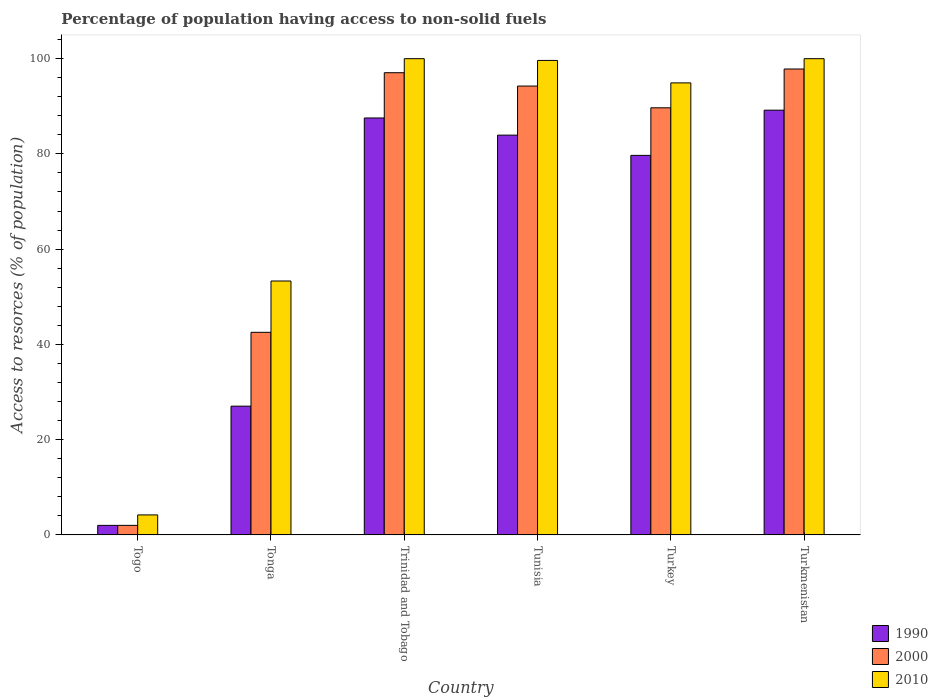How many groups of bars are there?
Offer a very short reply. 6. Are the number of bars on each tick of the X-axis equal?
Give a very brief answer. Yes. How many bars are there on the 1st tick from the left?
Provide a succinct answer. 3. How many bars are there on the 5th tick from the right?
Ensure brevity in your answer.  3. What is the label of the 2nd group of bars from the left?
Offer a terse response. Tonga. What is the percentage of population having access to non-solid fuels in 1990 in Tonga?
Give a very brief answer. 27.03. Across all countries, what is the maximum percentage of population having access to non-solid fuels in 2000?
Provide a short and direct response. 97.82. Across all countries, what is the minimum percentage of population having access to non-solid fuels in 2010?
Your answer should be compact. 4.19. In which country was the percentage of population having access to non-solid fuels in 2000 maximum?
Ensure brevity in your answer.  Turkmenistan. In which country was the percentage of population having access to non-solid fuels in 2000 minimum?
Provide a short and direct response. Togo. What is the total percentage of population having access to non-solid fuels in 2000 in the graph?
Provide a succinct answer. 423.32. What is the difference between the percentage of population having access to non-solid fuels in 1990 in Tonga and that in Trinidad and Tobago?
Ensure brevity in your answer.  -60.51. What is the difference between the percentage of population having access to non-solid fuels in 2010 in Tunisia and the percentage of population having access to non-solid fuels in 1990 in Turkey?
Your response must be concise. 19.94. What is the average percentage of population having access to non-solid fuels in 2010 per country?
Your answer should be very brief. 75.34. What is the difference between the percentage of population having access to non-solid fuels of/in 2000 and percentage of population having access to non-solid fuels of/in 1990 in Tonga?
Your answer should be compact. 15.51. What is the ratio of the percentage of population having access to non-solid fuels in 2010 in Tonga to that in Turkey?
Your answer should be compact. 0.56. Is the difference between the percentage of population having access to non-solid fuels in 2000 in Trinidad and Tobago and Turkey greater than the difference between the percentage of population having access to non-solid fuels in 1990 in Trinidad and Tobago and Turkey?
Offer a very short reply. No. What is the difference between the highest and the second highest percentage of population having access to non-solid fuels in 2000?
Provide a short and direct response. -3.58. What is the difference between the highest and the lowest percentage of population having access to non-solid fuels in 2010?
Your response must be concise. 95.8. Is the sum of the percentage of population having access to non-solid fuels in 1990 in Trinidad and Tobago and Turkey greater than the maximum percentage of population having access to non-solid fuels in 2010 across all countries?
Your answer should be compact. Yes. What does the 2nd bar from the left in Togo represents?
Your response must be concise. 2000. Is it the case that in every country, the sum of the percentage of population having access to non-solid fuels in 2000 and percentage of population having access to non-solid fuels in 1990 is greater than the percentage of population having access to non-solid fuels in 2010?
Your answer should be compact. No. How many bars are there?
Offer a terse response. 18. Are all the bars in the graph horizontal?
Your response must be concise. No. What is the difference between two consecutive major ticks on the Y-axis?
Your answer should be compact. 20. Does the graph contain any zero values?
Offer a terse response. No. Does the graph contain grids?
Provide a succinct answer. No. Where does the legend appear in the graph?
Offer a very short reply. Bottom right. How many legend labels are there?
Ensure brevity in your answer.  3. What is the title of the graph?
Ensure brevity in your answer.  Percentage of population having access to non-solid fuels. What is the label or title of the Y-axis?
Keep it short and to the point. Access to resorces (% of population). What is the Access to resorces (% of population) in 1990 in Togo?
Keep it short and to the point. 2. What is the Access to resorces (% of population) of 2000 in Togo?
Make the answer very short. 2. What is the Access to resorces (% of population) of 2010 in Togo?
Your answer should be compact. 4.19. What is the Access to resorces (% of population) of 1990 in Tonga?
Offer a terse response. 27.03. What is the Access to resorces (% of population) in 2000 in Tonga?
Give a very brief answer. 42.54. What is the Access to resorces (% of population) in 2010 in Tonga?
Your response must be concise. 53.31. What is the Access to resorces (% of population) in 1990 in Trinidad and Tobago?
Give a very brief answer. 87.54. What is the Access to resorces (% of population) of 2000 in Trinidad and Tobago?
Your answer should be very brief. 97.04. What is the Access to resorces (% of population) of 2010 in Trinidad and Tobago?
Your answer should be compact. 99.99. What is the Access to resorces (% of population) in 1990 in Tunisia?
Offer a very short reply. 83.94. What is the Access to resorces (% of population) in 2000 in Tunisia?
Ensure brevity in your answer.  94.24. What is the Access to resorces (% of population) in 2010 in Tunisia?
Offer a terse response. 99.62. What is the Access to resorces (% of population) of 1990 in Turkey?
Make the answer very short. 79.69. What is the Access to resorces (% of population) of 2000 in Turkey?
Keep it short and to the point. 89.68. What is the Access to resorces (% of population) of 2010 in Turkey?
Provide a succinct answer. 94.91. What is the Access to resorces (% of population) of 1990 in Turkmenistan?
Provide a succinct answer. 89.18. What is the Access to resorces (% of population) in 2000 in Turkmenistan?
Keep it short and to the point. 97.82. What is the Access to resorces (% of population) in 2010 in Turkmenistan?
Ensure brevity in your answer.  99.99. Across all countries, what is the maximum Access to resorces (% of population) in 1990?
Your answer should be compact. 89.18. Across all countries, what is the maximum Access to resorces (% of population) of 2000?
Give a very brief answer. 97.82. Across all countries, what is the maximum Access to resorces (% of population) of 2010?
Provide a succinct answer. 99.99. Across all countries, what is the minimum Access to resorces (% of population) of 1990?
Give a very brief answer. 2. Across all countries, what is the minimum Access to resorces (% of population) in 2000?
Keep it short and to the point. 2. Across all countries, what is the minimum Access to resorces (% of population) in 2010?
Provide a short and direct response. 4.19. What is the total Access to resorces (% of population) of 1990 in the graph?
Make the answer very short. 369.37. What is the total Access to resorces (% of population) of 2000 in the graph?
Make the answer very short. 423.32. What is the total Access to resorces (% of population) of 2010 in the graph?
Your answer should be very brief. 452.01. What is the difference between the Access to resorces (% of population) in 1990 in Togo and that in Tonga?
Make the answer very short. -25.03. What is the difference between the Access to resorces (% of population) of 2000 in Togo and that in Tonga?
Make the answer very short. -40.54. What is the difference between the Access to resorces (% of population) in 2010 in Togo and that in Tonga?
Your answer should be very brief. -49.11. What is the difference between the Access to resorces (% of population) in 1990 in Togo and that in Trinidad and Tobago?
Your answer should be very brief. -85.54. What is the difference between the Access to resorces (% of population) in 2000 in Togo and that in Trinidad and Tobago?
Provide a succinct answer. -95.04. What is the difference between the Access to resorces (% of population) of 2010 in Togo and that in Trinidad and Tobago?
Your answer should be compact. -95.8. What is the difference between the Access to resorces (% of population) of 1990 in Togo and that in Tunisia?
Provide a short and direct response. -81.94. What is the difference between the Access to resorces (% of population) of 2000 in Togo and that in Tunisia?
Your answer should be very brief. -92.24. What is the difference between the Access to resorces (% of population) of 2010 in Togo and that in Tunisia?
Make the answer very short. -95.43. What is the difference between the Access to resorces (% of population) in 1990 in Togo and that in Turkey?
Your answer should be very brief. -77.69. What is the difference between the Access to resorces (% of population) in 2000 in Togo and that in Turkey?
Your answer should be compact. -87.68. What is the difference between the Access to resorces (% of population) of 2010 in Togo and that in Turkey?
Give a very brief answer. -90.72. What is the difference between the Access to resorces (% of population) of 1990 in Togo and that in Turkmenistan?
Provide a succinct answer. -87.18. What is the difference between the Access to resorces (% of population) in 2000 in Togo and that in Turkmenistan?
Your answer should be very brief. -95.82. What is the difference between the Access to resorces (% of population) of 2010 in Togo and that in Turkmenistan?
Offer a very short reply. -95.8. What is the difference between the Access to resorces (% of population) of 1990 in Tonga and that in Trinidad and Tobago?
Offer a very short reply. -60.51. What is the difference between the Access to resorces (% of population) in 2000 in Tonga and that in Trinidad and Tobago?
Offer a terse response. -54.51. What is the difference between the Access to resorces (% of population) of 2010 in Tonga and that in Trinidad and Tobago?
Your answer should be compact. -46.68. What is the difference between the Access to resorces (% of population) in 1990 in Tonga and that in Tunisia?
Your answer should be compact. -56.91. What is the difference between the Access to resorces (% of population) of 2000 in Tonga and that in Tunisia?
Ensure brevity in your answer.  -51.71. What is the difference between the Access to resorces (% of population) in 2010 in Tonga and that in Tunisia?
Provide a succinct answer. -46.32. What is the difference between the Access to resorces (% of population) in 1990 in Tonga and that in Turkey?
Provide a short and direct response. -52.66. What is the difference between the Access to resorces (% of population) in 2000 in Tonga and that in Turkey?
Ensure brevity in your answer.  -47.14. What is the difference between the Access to resorces (% of population) in 2010 in Tonga and that in Turkey?
Your answer should be very brief. -41.6. What is the difference between the Access to resorces (% of population) in 1990 in Tonga and that in Turkmenistan?
Give a very brief answer. -62.15. What is the difference between the Access to resorces (% of population) of 2000 in Tonga and that in Turkmenistan?
Your answer should be compact. -55.29. What is the difference between the Access to resorces (% of population) of 2010 in Tonga and that in Turkmenistan?
Your response must be concise. -46.68. What is the difference between the Access to resorces (% of population) in 1990 in Trinidad and Tobago and that in Tunisia?
Keep it short and to the point. 3.6. What is the difference between the Access to resorces (% of population) in 2000 in Trinidad and Tobago and that in Tunisia?
Give a very brief answer. 2.8. What is the difference between the Access to resorces (% of population) in 2010 in Trinidad and Tobago and that in Tunisia?
Ensure brevity in your answer.  0.37. What is the difference between the Access to resorces (% of population) of 1990 in Trinidad and Tobago and that in Turkey?
Offer a very short reply. 7.85. What is the difference between the Access to resorces (% of population) in 2000 in Trinidad and Tobago and that in Turkey?
Ensure brevity in your answer.  7.37. What is the difference between the Access to resorces (% of population) in 2010 in Trinidad and Tobago and that in Turkey?
Ensure brevity in your answer.  5.08. What is the difference between the Access to resorces (% of population) of 1990 in Trinidad and Tobago and that in Turkmenistan?
Ensure brevity in your answer.  -1.64. What is the difference between the Access to resorces (% of population) in 2000 in Trinidad and Tobago and that in Turkmenistan?
Your answer should be very brief. -0.78. What is the difference between the Access to resorces (% of population) of 1990 in Tunisia and that in Turkey?
Offer a terse response. 4.25. What is the difference between the Access to resorces (% of population) in 2000 in Tunisia and that in Turkey?
Your answer should be compact. 4.57. What is the difference between the Access to resorces (% of population) in 2010 in Tunisia and that in Turkey?
Your response must be concise. 4.71. What is the difference between the Access to resorces (% of population) in 1990 in Tunisia and that in Turkmenistan?
Provide a succinct answer. -5.24. What is the difference between the Access to resorces (% of population) in 2000 in Tunisia and that in Turkmenistan?
Give a very brief answer. -3.58. What is the difference between the Access to resorces (% of population) of 2010 in Tunisia and that in Turkmenistan?
Give a very brief answer. -0.37. What is the difference between the Access to resorces (% of population) in 1990 in Turkey and that in Turkmenistan?
Provide a short and direct response. -9.49. What is the difference between the Access to resorces (% of population) in 2000 in Turkey and that in Turkmenistan?
Give a very brief answer. -8.14. What is the difference between the Access to resorces (% of population) of 2010 in Turkey and that in Turkmenistan?
Your response must be concise. -5.08. What is the difference between the Access to resorces (% of population) of 1990 in Togo and the Access to resorces (% of population) of 2000 in Tonga?
Ensure brevity in your answer.  -40.54. What is the difference between the Access to resorces (% of population) of 1990 in Togo and the Access to resorces (% of population) of 2010 in Tonga?
Keep it short and to the point. -51.31. What is the difference between the Access to resorces (% of population) of 2000 in Togo and the Access to resorces (% of population) of 2010 in Tonga?
Provide a succinct answer. -51.31. What is the difference between the Access to resorces (% of population) of 1990 in Togo and the Access to resorces (% of population) of 2000 in Trinidad and Tobago?
Your response must be concise. -95.04. What is the difference between the Access to resorces (% of population) of 1990 in Togo and the Access to resorces (% of population) of 2010 in Trinidad and Tobago?
Make the answer very short. -97.99. What is the difference between the Access to resorces (% of population) of 2000 in Togo and the Access to resorces (% of population) of 2010 in Trinidad and Tobago?
Your answer should be very brief. -97.99. What is the difference between the Access to resorces (% of population) in 1990 in Togo and the Access to resorces (% of population) in 2000 in Tunisia?
Your answer should be very brief. -92.24. What is the difference between the Access to resorces (% of population) of 1990 in Togo and the Access to resorces (% of population) of 2010 in Tunisia?
Offer a terse response. -97.62. What is the difference between the Access to resorces (% of population) of 2000 in Togo and the Access to resorces (% of population) of 2010 in Tunisia?
Make the answer very short. -97.62. What is the difference between the Access to resorces (% of population) in 1990 in Togo and the Access to resorces (% of population) in 2000 in Turkey?
Provide a short and direct response. -87.68. What is the difference between the Access to resorces (% of population) in 1990 in Togo and the Access to resorces (% of population) in 2010 in Turkey?
Ensure brevity in your answer.  -92.91. What is the difference between the Access to resorces (% of population) of 2000 in Togo and the Access to resorces (% of population) of 2010 in Turkey?
Ensure brevity in your answer.  -92.91. What is the difference between the Access to resorces (% of population) in 1990 in Togo and the Access to resorces (% of population) in 2000 in Turkmenistan?
Make the answer very short. -95.82. What is the difference between the Access to resorces (% of population) in 1990 in Togo and the Access to resorces (% of population) in 2010 in Turkmenistan?
Provide a succinct answer. -97.99. What is the difference between the Access to resorces (% of population) in 2000 in Togo and the Access to resorces (% of population) in 2010 in Turkmenistan?
Keep it short and to the point. -97.99. What is the difference between the Access to resorces (% of population) in 1990 in Tonga and the Access to resorces (% of population) in 2000 in Trinidad and Tobago?
Provide a succinct answer. -70.02. What is the difference between the Access to resorces (% of population) in 1990 in Tonga and the Access to resorces (% of population) in 2010 in Trinidad and Tobago?
Your answer should be compact. -72.96. What is the difference between the Access to resorces (% of population) of 2000 in Tonga and the Access to resorces (% of population) of 2010 in Trinidad and Tobago?
Your answer should be very brief. -57.45. What is the difference between the Access to resorces (% of population) in 1990 in Tonga and the Access to resorces (% of population) in 2000 in Tunisia?
Make the answer very short. -67.21. What is the difference between the Access to resorces (% of population) of 1990 in Tonga and the Access to resorces (% of population) of 2010 in Tunisia?
Your response must be concise. -72.59. What is the difference between the Access to resorces (% of population) of 2000 in Tonga and the Access to resorces (% of population) of 2010 in Tunisia?
Ensure brevity in your answer.  -57.09. What is the difference between the Access to resorces (% of population) of 1990 in Tonga and the Access to resorces (% of population) of 2000 in Turkey?
Your answer should be very brief. -62.65. What is the difference between the Access to resorces (% of population) in 1990 in Tonga and the Access to resorces (% of population) in 2010 in Turkey?
Offer a terse response. -67.88. What is the difference between the Access to resorces (% of population) of 2000 in Tonga and the Access to resorces (% of population) of 2010 in Turkey?
Make the answer very short. -52.37. What is the difference between the Access to resorces (% of population) of 1990 in Tonga and the Access to resorces (% of population) of 2000 in Turkmenistan?
Offer a terse response. -70.79. What is the difference between the Access to resorces (% of population) in 1990 in Tonga and the Access to resorces (% of population) in 2010 in Turkmenistan?
Provide a succinct answer. -72.96. What is the difference between the Access to resorces (% of population) in 2000 in Tonga and the Access to resorces (% of population) in 2010 in Turkmenistan?
Provide a short and direct response. -57.45. What is the difference between the Access to resorces (% of population) in 1990 in Trinidad and Tobago and the Access to resorces (% of population) in 2000 in Tunisia?
Give a very brief answer. -6.7. What is the difference between the Access to resorces (% of population) in 1990 in Trinidad and Tobago and the Access to resorces (% of population) in 2010 in Tunisia?
Your answer should be very brief. -12.08. What is the difference between the Access to resorces (% of population) in 2000 in Trinidad and Tobago and the Access to resorces (% of population) in 2010 in Tunisia?
Your answer should be very brief. -2.58. What is the difference between the Access to resorces (% of population) of 1990 in Trinidad and Tobago and the Access to resorces (% of population) of 2000 in Turkey?
Offer a very short reply. -2.14. What is the difference between the Access to resorces (% of population) in 1990 in Trinidad and Tobago and the Access to resorces (% of population) in 2010 in Turkey?
Your answer should be very brief. -7.37. What is the difference between the Access to resorces (% of population) in 2000 in Trinidad and Tobago and the Access to resorces (% of population) in 2010 in Turkey?
Provide a short and direct response. 2.14. What is the difference between the Access to resorces (% of population) in 1990 in Trinidad and Tobago and the Access to resorces (% of population) in 2000 in Turkmenistan?
Your answer should be compact. -10.28. What is the difference between the Access to resorces (% of population) of 1990 in Trinidad and Tobago and the Access to resorces (% of population) of 2010 in Turkmenistan?
Provide a short and direct response. -12.45. What is the difference between the Access to resorces (% of population) of 2000 in Trinidad and Tobago and the Access to resorces (% of population) of 2010 in Turkmenistan?
Give a very brief answer. -2.95. What is the difference between the Access to resorces (% of population) of 1990 in Tunisia and the Access to resorces (% of population) of 2000 in Turkey?
Your answer should be very brief. -5.74. What is the difference between the Access to resorces (% of population) in 1990 in Tunisia and the Access to resorces (% of population) in 2010 in Turkey?
Ensure brevity in your answer.  -10.97. What is the difference between the Access to resorces (% of population) in 2000 in Tunisia and the Access to resorces (% of population) in 2010 in Turkey?
Offer a terse response. -0.67. What is the difference between the Access to resorces (% of population) in 1990 in Tunisia and the Access to resorces (% of population) in 2000 in Turkmenistan?
Ensure brevity in your answer.  -13.88. What is the difference between the Access to resorces (% of population) of 1990 in Tunisia and the Access to resorces (% of population) of 2010 in Turkmenistan?
Provide a short and direct response. -16.05. What is the difference between the Access to resorces (% of population) of 2000 in Tunisia and the Access to resorces (% of population) of 2010 in Turkmenistan?
Offer a terse response. -5.75. What is the difference between the Access to resorces (% of population) of 1990 in Turkey and the Access to resorces (% of population) of 2000 in Turkmenistan?
Offer a very short reply. -18.13. What is the difference between the Access to resorces (% of population) of 1990 in Turkey and the Access to resorces (% of population) of 2010 in Turkmenistan?
Your answer should be very brief. -20.3. What is the difference between the Access to resorces (% of population) in 2000 in Turkey and the Access to resorces (% of population) in 2010 in Turkmenistan?
Give a very brief answer. -10.31. What is the average Access to resorces (% of population) of 1990 per country?
Your response must be concise. 61.56. What is the average Access to resorces (% of population) in 2000 per country?
Offer a terse response. 70.55. What is the average Access to resorces (% of population) of 2010 per country?
Ensure brevity in your answer.  75.34. What is the difference between the Access to resorces (% of population) of 1990 and Access to resorces (% of population) of 2000 in Togo?
Keep it short and to the point. -0. What is the difference between the Access to resorces (% of population) in 1990 and Access to resorces (% of population) in 2010 in Togo?
Your answer should be compact. -2.19. What is the difference between the Access to resorces (% of population) in 2000 and Access to resorces (% of population) in 2010 in Togo?
Ensure brevity in your answer.  -2.19. What is the difference between the Access to resorces (% of population) of 1990 and Access to resorces (% of population) of 2000 in Tonga?
Make the answer very short. -15.51. What is the difference between the Access to resorces (% of population) of 1990 and Access to resorces (% of population) of 2010 in Tonga?
Provide a short and direct response. -26.28. What is the difference between the Access to resorces (% of population) in 2000 and Access to resorces (% of population) in 2010 in Tonga?
Ensure brevity in your answer.  -10.77. What is the difference between the Access to resorces (% of population) in 1990 and Access to resorces (% of population) in 2000 in Trinidad and Tobago?
Give a very brief answer. -9.51. What is the difference between the Access to resorces (% of population) of 1990 and Access to resorces (% of population) of 2010 in Trinidad and Tobago?
Provide a succinct answer. -12.45. What is the difference between the Access to resorces (% of population) in 2000 and Access to resorces (% of population) in 2010 in Trinidad and Tobago?
Keep it short and to the point. -2.95. What is the difference between the Access to resorces (% of population) in 1990 and Access to resorces (% of population) in 2000 in Tunisia?
Your answer should be very brief. -10.3. What is the difference between the Access to resorces (% of population) of 1990 and Access to resorces (% of population) of 2010 in Tunisia?
Keep it short and to the point. -15.69. What is the difference between the Access to resorces (% of population) of 2000 and Access to resorces (% of population) of 2010 in Tunisia?
Give a very brief answer. -5.38. What is the difference between the Access to resorces (% of population) in 1990 and Access to resorces (% of population) in 2000 in Turkey?
Offer a very short reply. -9.99. What is the difference between the Access to resorces (% of population) in 1990 and Access to resorces (% of population) in 2010 in Turkey?
Your answer should be very brief. -15.22. What is the difference between the Access to resorces (% of population) of 2000 and Access to resorces (% of population) of 2010 in Turkey?
Offer a terse response. -5.23. What is the difference between the Access to resorces (% of population) of 1990 and Access to resorces (% of population) of 2000 in Turkmenistan?
Your answer should be very brief. -8.64. What is the difference between the Access to resorces (% of population) in 1990 and Access to resorces (% of population) in 2010 in Turkmenistan?
Ensure brevity in your answer.  -10.81. What is the difference between the Access to resorces (% of population) of 2000 and Access to resorces (% of population) of 2010 in Turkmenistan?
Offer a very short reply. -2.17. What is the ratio of the Access to resorces (% of population) of 1990 in Togo to that in Tonga?
Provide a succinct answer. 0.07. What is the ratio of the Access to resorces (% of population) in 2000 in Togo to that in Tonga?
Offer a terse response. 0.05. What is the ratio of the Access to resorces (% of population) in 2010 in Togo to that in Tonga?
Offer a terse response. 0.08. What is the ratio of the Access to resorces (% of population) of 1990 in Togo to that in Trinidad and Tobago?
Ensure brevity in your answer.  0.02. What is the ratio of the Access to resorces (% of population) of 2000 in Togo to that in Trinidad and Tobago?
Provide a short and direct response. 0.02. What is the ratio of the Access to resorces (% of population) in 2010 in Togo to that in Trinidad and Tobago?
Provide a short and direct response. 0.04. What is the ratio of the Access to resorces (% of population) in 1990 in Togo to that in Tunisia?
Provide a succinct answer. 0.02. What is the ratio of the Access to resorces (% of population) of 2000 in Togo to that in Tunisia?
Keep it short and to the point. 0.02. What is the ratio of the Access to resorces (% of population) of 2010 in Togo to that in Tunisia?
Ensure brevity in your answer.  0.04. What is the ratio of the Access to resorces (% of population) in 1990 in Togo to that in Turkey?
Your answer should be compact. 0.03. What is the ratio of the Access to resorces (% of population) in 2000 in Togo to that in Turkey?
Your response must be concise. 0.02. What is the ratio of the Access to resorces (% of population) in 2010 in Togo to that in Turkey?
Provide a short and direct response. 0.04. What is the ratio of the Access to resorces (% of population) of 1990 in Togo to that in Turkmenistan?
Offer a very short reply. 0.02. What is the ratio of the Access to resorces (% of population) in 2000 in Togo to that in Turkmenistan?
Provide a succinct answer. 0.02. What is the ratio of the Access to resorces (% of population) in 2010 in Togo to that in Turkmenistan?
Keep it short and to the point. 0.04. What is the ratio of the Access to resorces (% of population) in 1990 in Tonga to that in Trinidad and Tobago?
Your answer should be very brief. 0.31. What is the ratio of the Access to resorces (% of population) in 2000 in Tonga to that in Trinidad and Tobago?
Ensure brevity in your answer.  0.44. What is the ratio of the Access to resorces (% of population) in 2010 in Tonga to that in Trinidad and Tobago?
Make the answer very short. 0.53. What is the ratio of the Access to resorces (% of population) in 1990 in Tonga to that in Tunisia?
Your answer should be compact. 0.32. What is the ratio of the Access to resorces (% of population) in 2000 in Tonga to that in Tunisia?
Provide a succinct answer. 0.45. What is the ratio of the Access to resorces (% of population) in 2010 in Tonga to that in Tunisia?
Your answer should be compact. 0.54. What is the ratio of the Access to resorces (% of population) of 1990 in Tonga to that in Turkey?
Make the answer very short. 0.34. What is the ratio of the Access to resorces (% of population) in 2000 in Tonga to that in Turkey?
Offer a terse response. 0.47. What is the ratio of the Access to resorces (% of population) in 2010 in Tonga to that in Turkey?
Give a very brief answer. 0.56. What is the ratio of the Access to resorces (% of population) of 1990 in Tonga to that in Turkmenistan?
Your answer should be very brief. 0.3. What is the ratio of the Access to resorces (% of population) in 2000 in Tonga to that in Turkmenistan?
Make the answer very short. 0.43. What is the ratio of the Access to resorces (% of population) of 2010 in Tonga to that in Turkmenistan?
Make the answer very short. 0.53. What is the ratio of the Access to resorces (% of population) of 1990 in Trinidad and Tobago to that in Tunisia?
Provide a succinct answer. 1.04. What is the ratio of the Access to resorces (% of population) in 2000 in Trinidad and Tobago to that in Tunisia?
Your answer should be compact. 1.03. What is the ratio of the Access to resorces (% of population) of 1990 in Trinidad and Tobago to that in Turkey?
Your answer should be very brief. 1.1. What is the ratio of the Access to resorces (% of population) of 2000 in Trinidad and Tobago to that in Turkey?
Your answer should be very brief. 1.08. What is the ratio of the Access to resorces (% of population) in 2010 in Trinidad and Tobago to that in Turkey?
Make the answer very short. 1.05. What is the ratio of the Access to resorces (% of population) of 1990 in Trinidad and Tobago to that in Turkmenistan?
Give a very brief answer. 0.98. What is the ratio of the Access to resorces (% of population) of 2000 in Trinidad and Tobago to that in Turkmenistan?
Your answer should be compact. 0.99. What is the ratio of the Access to resorces (% of population) in 2010 in Trinidad and Tobago to that in Turkmenistan?
Make the answer very short. 1. What is the ratio of the Access to resorces (% of population) in 1990 in Tunisia to that in Turkey?
Offer a terse response. 1.05. What is the ratio of the Access to resorces (% of population) in 2000 in Tunisia to that in Turkey?
Make the answer very short. 1.05. What is the ratio of the Access to resorces (% of population) in 2010 in Tunisia to that in Turkey?
Your answer should be very brief. 1.05. What is the ratio of the Access to resorces (% of population) in 1990 in Tunisia to that in Turkmenistan?
Make the answer very short. 0.94. What is the ratio of the Access to resorces (% of population) in 2000 in Tunisia to that in Turkmenistan?
Your answer should be compact. 0.96. What is the ratio of the Access to resorces (% of population) in 2010 in Tunisia to that in Turkmenistan?
Your answer should be very brief. 1. What is the ratio of the Access to resorces (% of population) in 1990 in Turkey to that in Turkmenistan?
Your response must be concise. 0.89. What is the ratio of the Access to resorces (% of population) in 2000 in Turkey to that in Turkmenistan?
Ensure brevity in your answer.  0.92. What is the ratio of the Access to resorces (% of population) in 2010 in Turkey to that in Turkmenistan?
Your answer should be very brief. 0.95. What is the difference between the highest and the second highest Access to resorces (% of population) of 1990?
Make the answer very short. 1.64. What is the difference between the highest and the second highest Access to resorces (% of population) of 2000?
Give a very brief answer. 0.78. What is the difference between the highest and the lowest Access to resorces (% of population) of 1990?
Your answer should be compact. 87.18. What is the difference between the highest and the lowest Access to resorces (% of population) in 2000?
Provide a short and direct response. 95.82. What is the difference between the highest and the lowest Access to resorces (% of population) of 2010?
Provide a succinct answer. 95.8. 